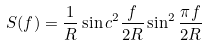<formula> <loc_0><loc_0><loc_500><loc_500>S ( f ) = \frac { 1 } { R } \sin c ^ { 2 } \frac { f } { 2 R } \sin ^ { 2 } \frac { \pi f } { 2 R }</formula> 